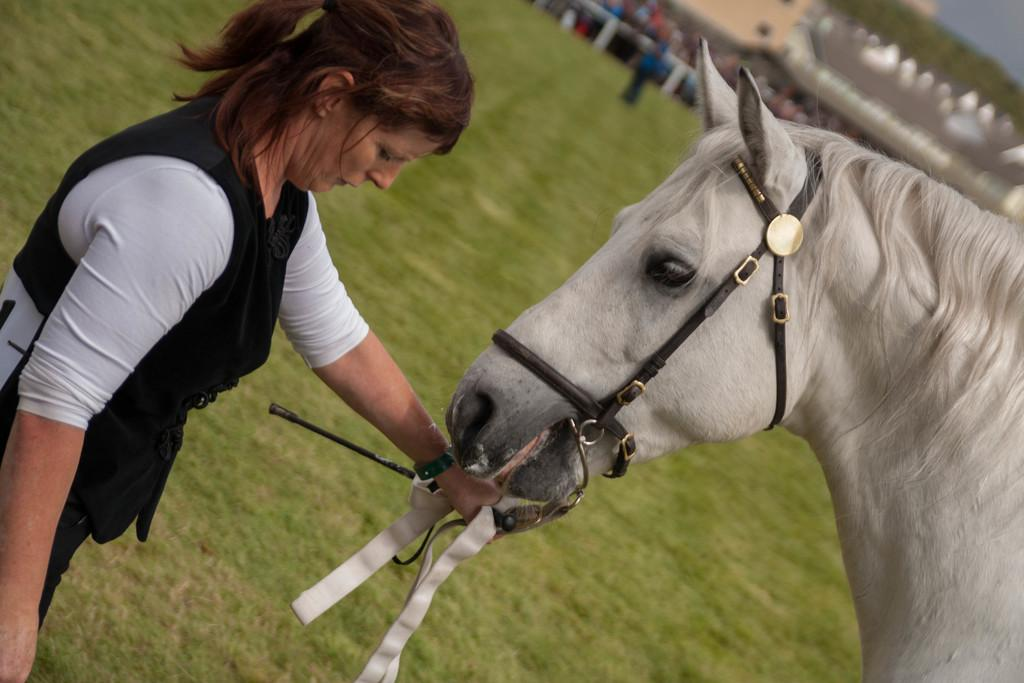Who is the main subject in the image? There is a lady in the image. What is the lady holding in the image? The lady is holding a horse. What can be seen in the background of the image? There are trees, people, and fencing visible in the background of the image. What level of activity is the lady engaged in with the horse in the image? The image does not provide information about the level of activity the lady is engaged in with the horse. 